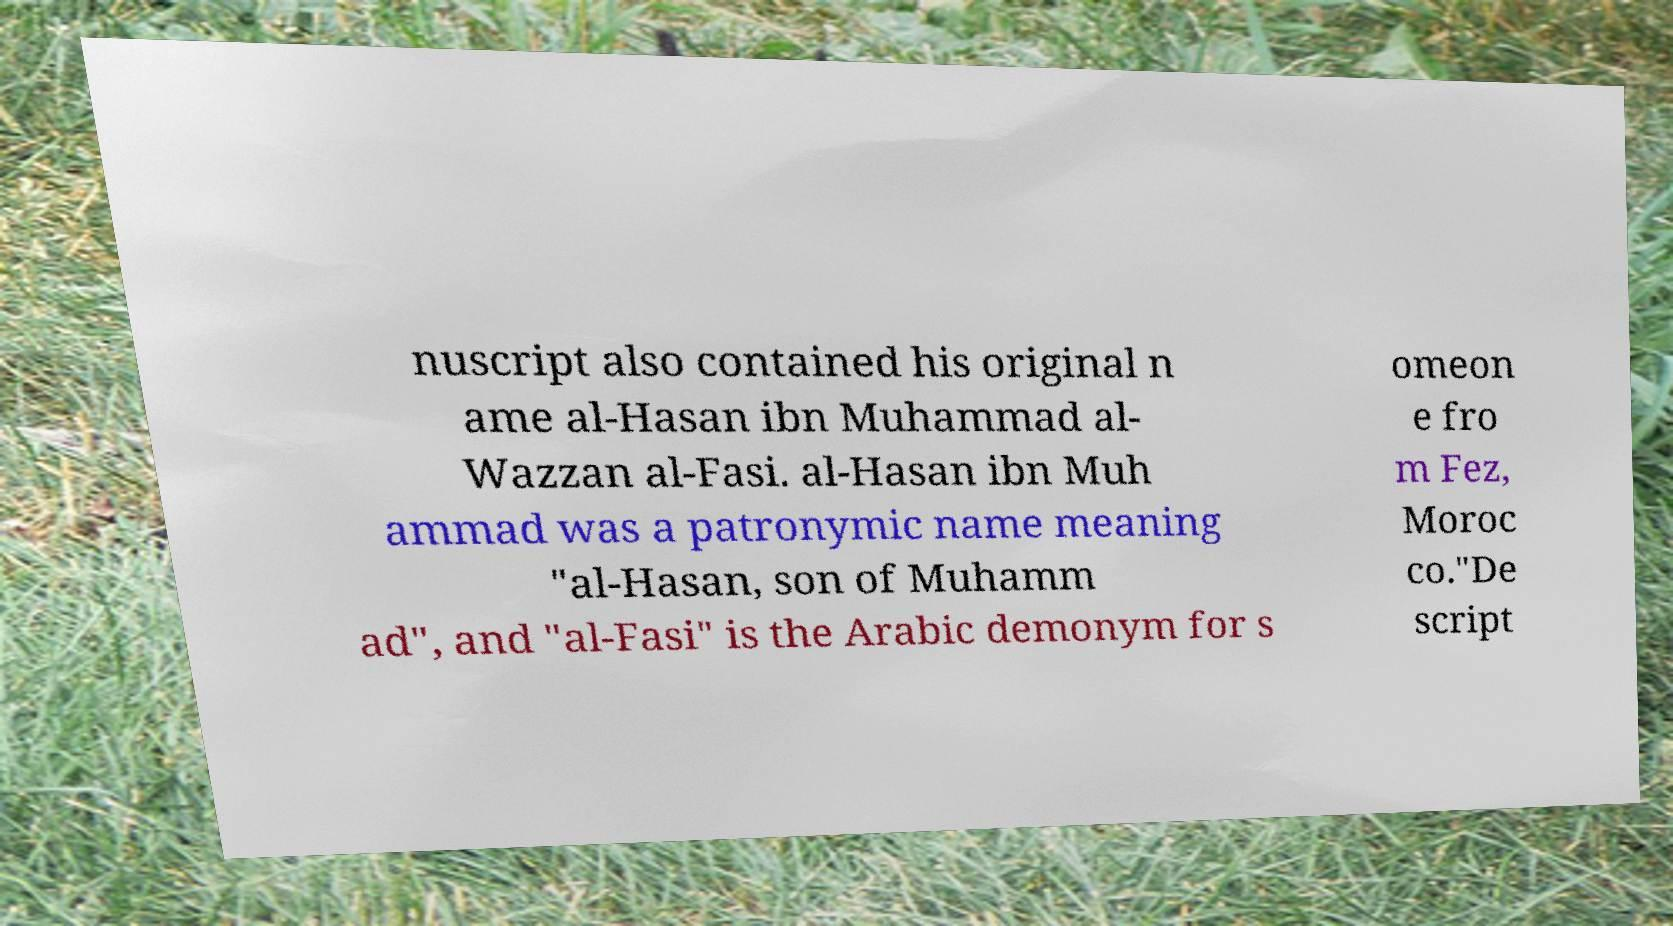Could you extract and type out the text from this image? nuscript also contained his original n ame al-Hasan ibn Muhammad al- Wazzan al-Fasi. al-Hasan ibn Muh ammad was a patronymic name meaning "al-Hasan, son of Muhamm ad", and "al-Fasi" is the Arabic demonym for s omeon e fro m Fez, Moroc co."De script 